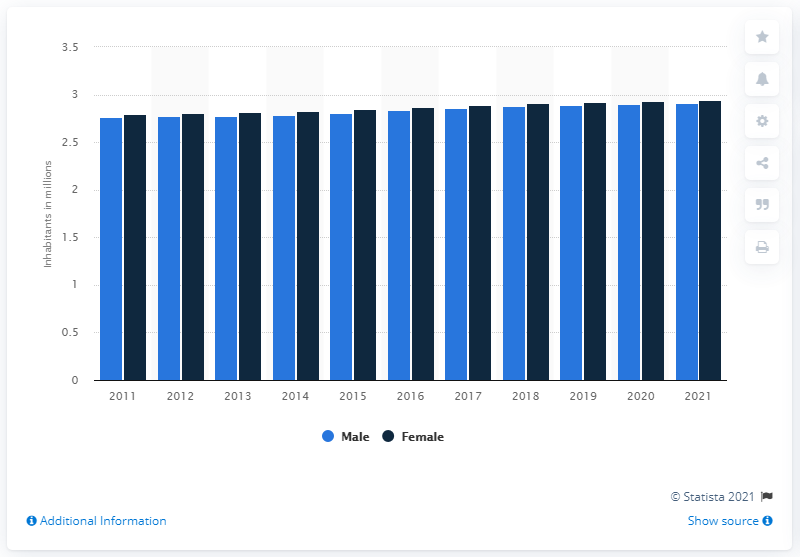Indicate a few pertinent items in this graphic. As of January 1st, 2021, the population of females in Denmark was 2.94 million. 